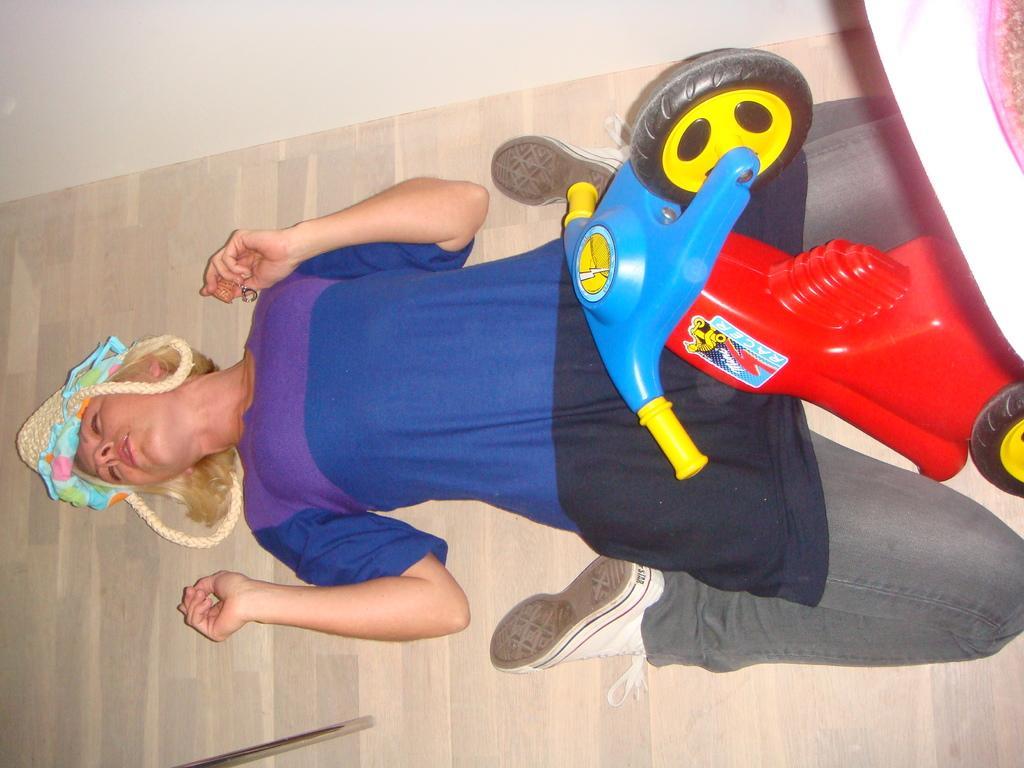Please provide a concise description of this image. In this image I can see a person wearing blue, purple and black colored dress is lying on the floor and a toy vehicle which is red, yellow, blue and black in color. I can see the wall to the top of the image. 